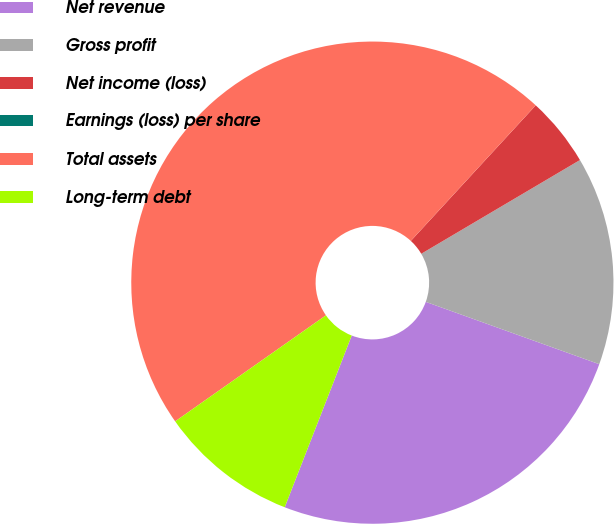<chart> <loc_0><loc_0><loc_500><loc_500><pie_chart><fcel>Net revenue<fcel>Gross profit<fcel>Net income (loss)<fcel>Earnings (loss) per share<fcel>Total assets<fcel>Long-term debt<nl><fcel>25.43%<fcel>13.98%<fcel>4.66%<fcel>0.0%<fcel>46.6%<fcel>9.32%<nl></chart> 